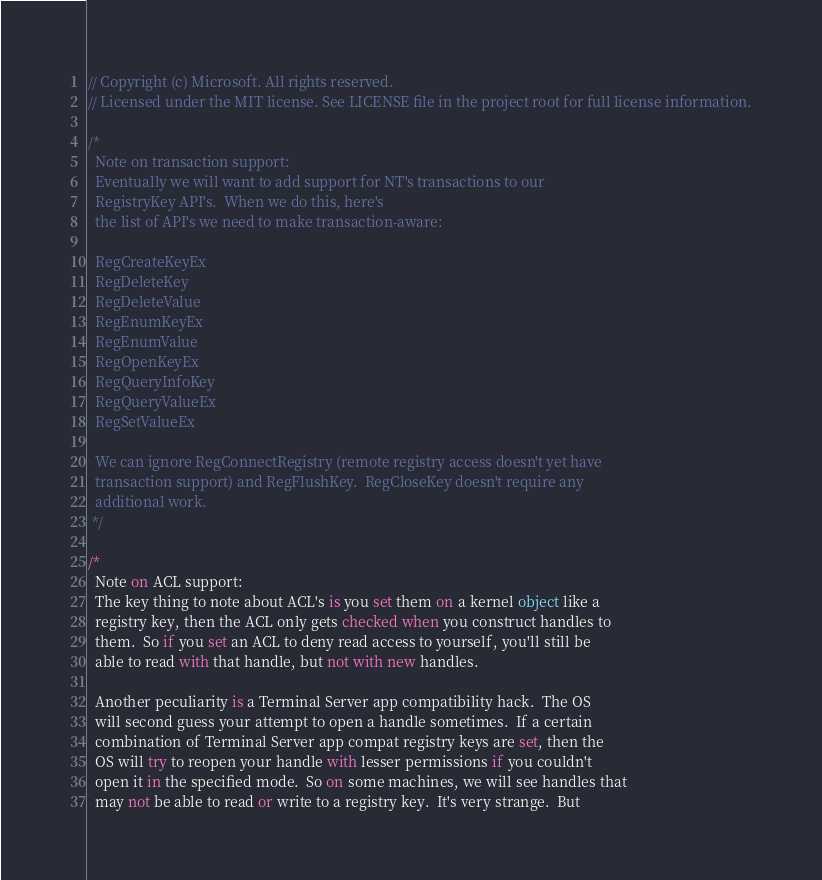Convert code to text. <code><loc_0><loc_0><loc_500><loc_500><_C#_>// Copyright (c) Microsoft. All rights reserved.
// Licensed under the MIT license. See LICENSE file in the project root for full license information.

/*
  Note on transaction support:
  Eventually we will want to add support for NT's transactions to our
  RegistryKey API's.  When we do this, here's
  the list of API's we need to make transaction-aware:

  RegCreateKeyEx
  RegDeleteKey
  RegDeleteValue
  RegEnumKeyEx
  RegEnumValue
  RegOpenKeyEx
  RegQueryInfoKey
  RegQueryValueEx
  RegSetValueEx

  We can ignore RegConnectRegistry (remote registry access doesn't yet have
  transaction support) and RegFlushKey.  RegCloseKey doesn't require any
  additional work.
 */

/*
  Note on ACL support:
  The key thing to note about ACL's is you set them on a kernel object like a
  registry key, then the ACL only gets checked when you construct handles to 
  them.  So if you set an ACL to deny read access to yourself, you'll still be
  able to read with that handle, but not with new handles.

  Another peculiarity is a Terminal Server app compatibility hack.  The OS
  will second guess your attempt to open a handle sometimes.  If a certain
  combination of Terminal Server app compat registry keys are set, then the
  OS will try to reopen your handle with lesser permissions if you couldn't
  open it in the specified mode.  So on some machines, we will see handles that
  may not be able to read or write to a registry key.  It's very strange.  But</code> 